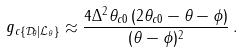<formula> <loc_0><loc_0><loc_500><loc_500>g _ { c \{ \mathcal { D } _ { \theta } | \mathcal { L } _ { \theta } \} } \approx \frac { 4 \Delta ^ { 2 } \theta _ { c 0 } \, ( 2 \theta _ { c 0 } - \theta - \phi ) } { ( \theta - \phi ) ^ { 2 } } \, .</formula> 